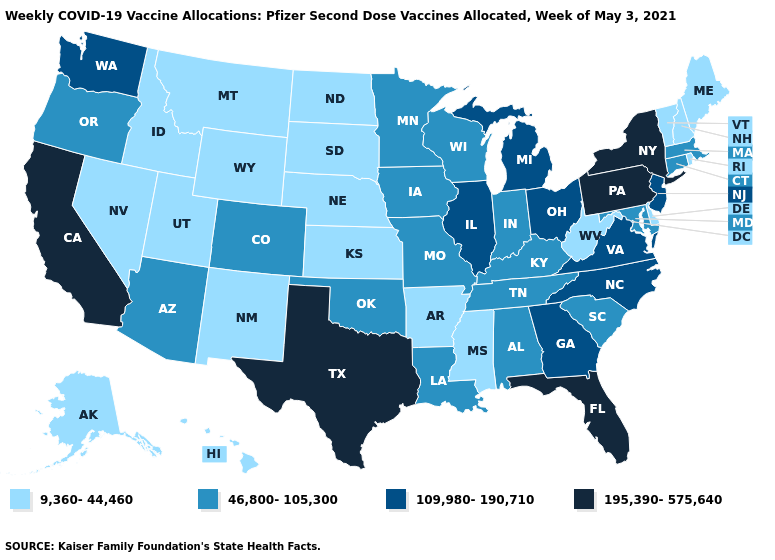Name the states that have a value in the range 195,390-575,640?
Short answer required. California, Florida, New York, Pennsylvania, Texas. Among the states that border Connecticut , which have the lowest value?
Quick response, please. Rhode Island. Which states have the highest value in the USA?
Keep it brief. California, Florida, New York, Pennsylvania, Texas. Is the legend a continuous bar?
Be succinct. No. Name the states that have a value in the range 109,980-190,710?
Write a very short answer. Georgia, Illinois, Michigan, New Jersey, North Carolina, Ohio, Virginia, Washington. What is the highest value in the South ?
Answer briefly. 195,390-575,640. Is the legend a continuous bar?
Short answer required. No. What is the value of Oregon?
Give a very brief answer. 46,800-105,300. Does New York have the lowest value in the Northeast?
Quick response, please. No. Which states hav the highest value in the Northeast?
Write a very short answer. New York, Pennsylvania. Does Nevada have a lower value than Maine?
Answer briefly. No. Is the legend a continuous bar?
Quick response, please. No. Does Ohio have the highest value in the MidWest?
Answer briefly. Yes. Is the legend a continuous bar?
Be succinct. No. Name the states that have a value in the range 9,360-44,460?
Concise answer only. Alaska, Arkansas, Delaware, Hawaii, Idaho, Kansas, Maine, Mississippi, Montana, Nebraska, Nevada, New Hampshire, New Mexico, North Dakota, Rhode Island, South Dakota, Utah, Vermont, West Virginia, Wyoming. 